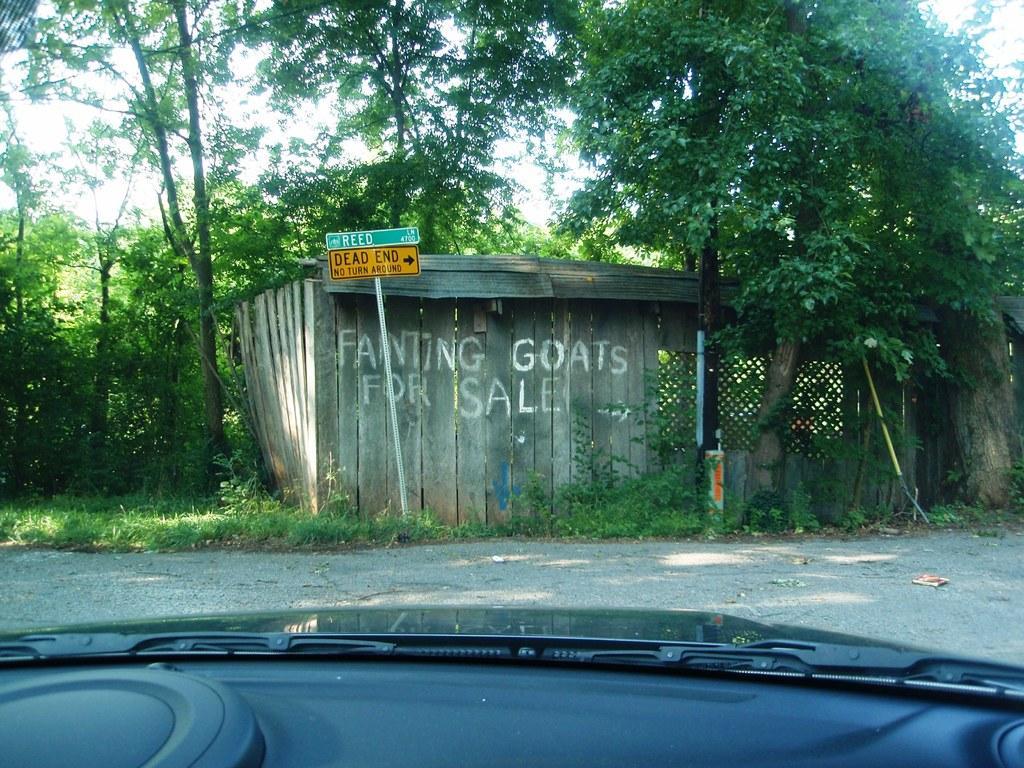Could you give a brief overview of what you see in this image? It is the glass of a vehicle, outside this there is a shed and there are green color trees. 